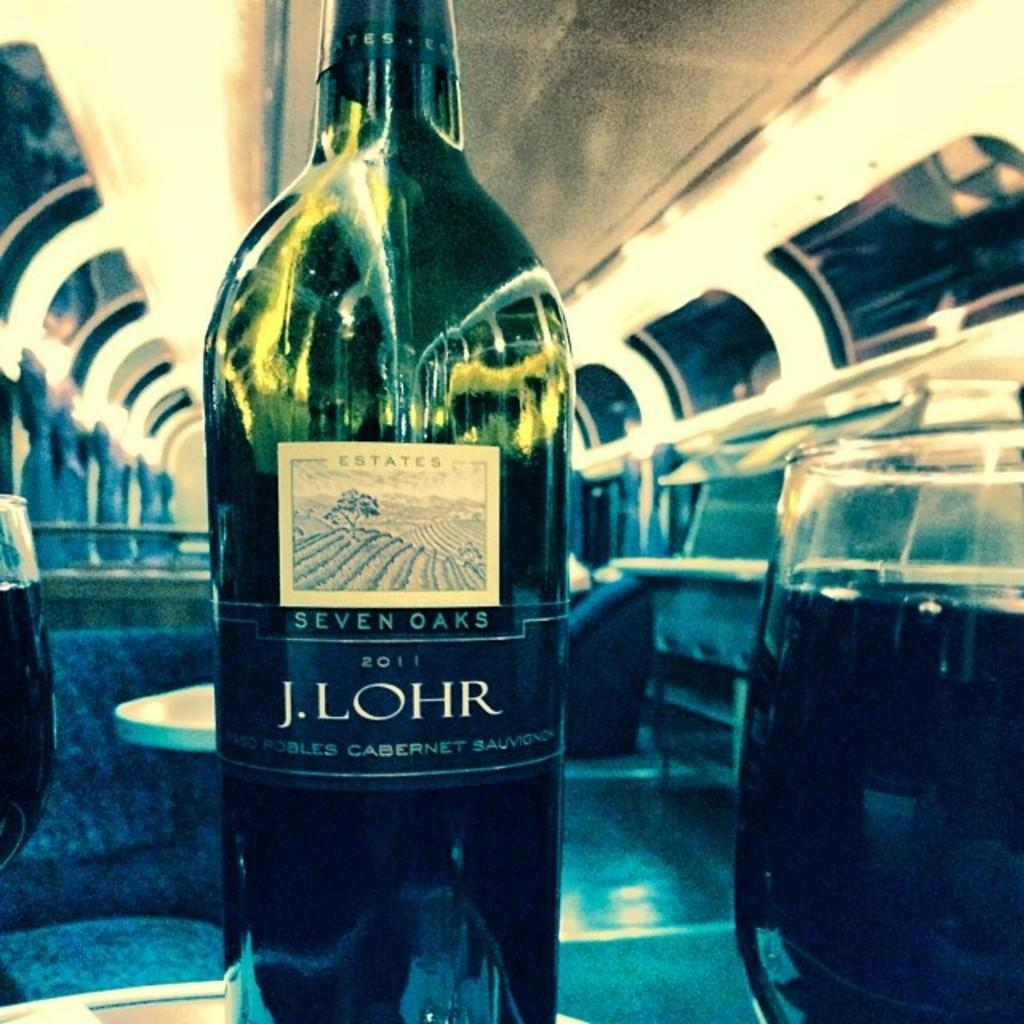<image>
Relay a brief, clear account of the picture shown. A bottle of Seven Oaks Cabernet Sauvignon 2011 is displayed in an exmpty train car. 